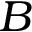<formula> <loc_0><loc_0><loc_500><loc_500>B</formula> 